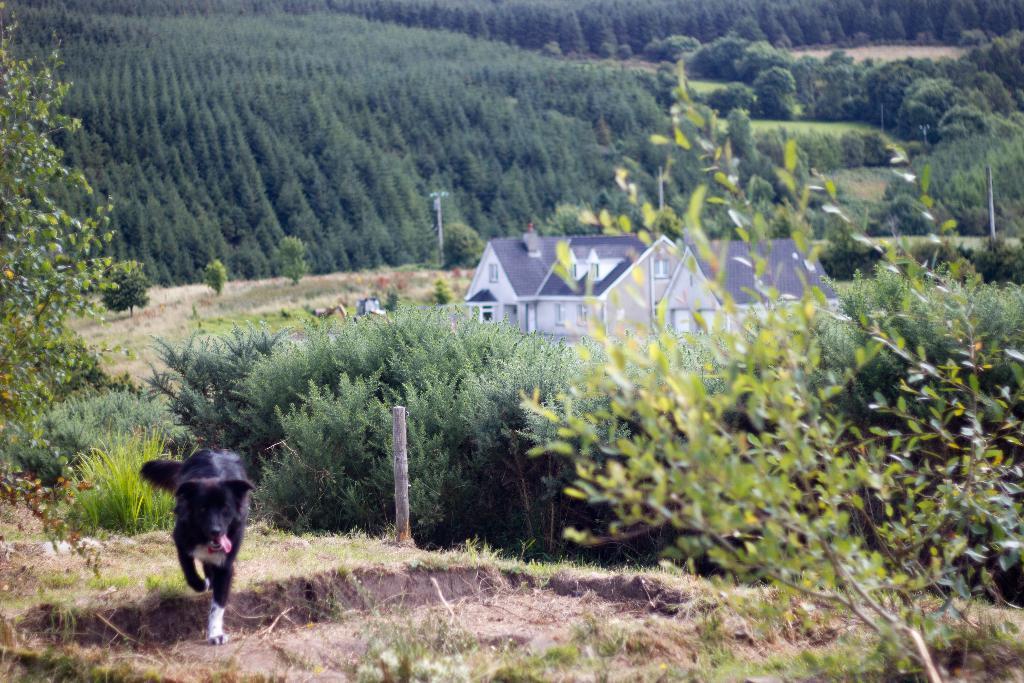In one or two sentences, can you explain what this image depicts? In this image we can see a dog on the ground, there are some trees, poles, grass, plants and houses. 